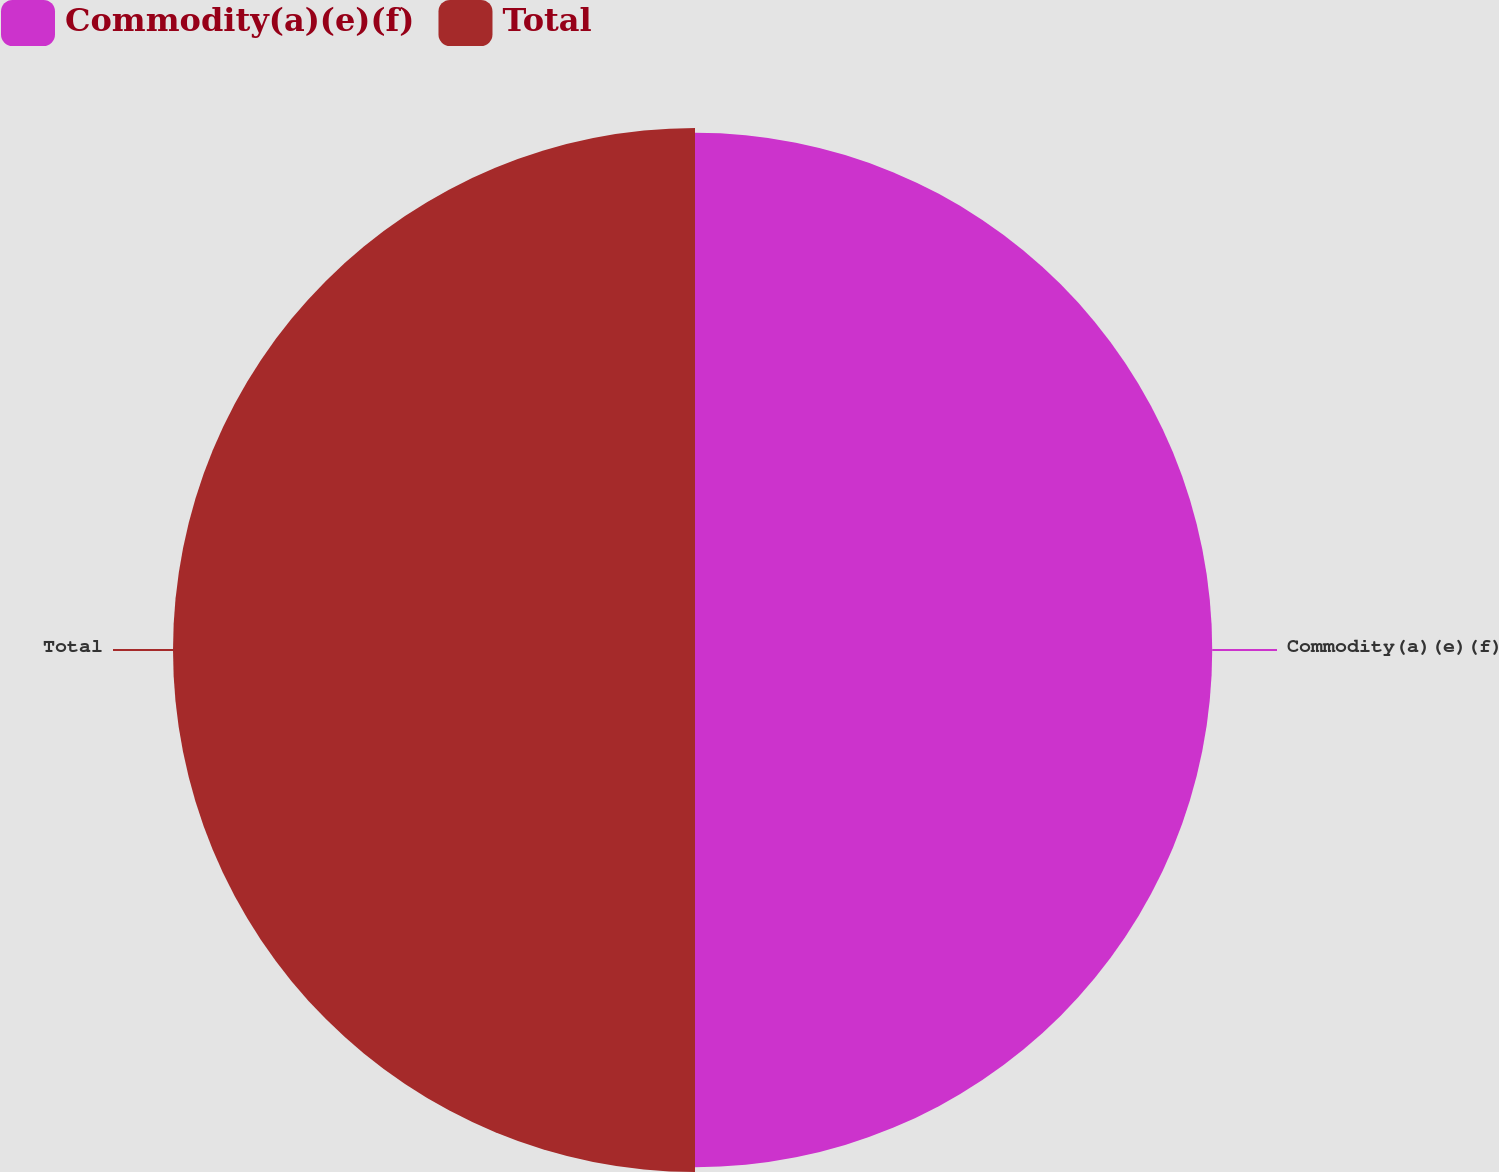<chart> <loc_0><loc_0><loc_500><loc_500><pie_chart><fcel>Commodity(a)(e)(f)<fcel>Total<nl><fcel>49.77%<fcel>50.23%<nl></chart> 